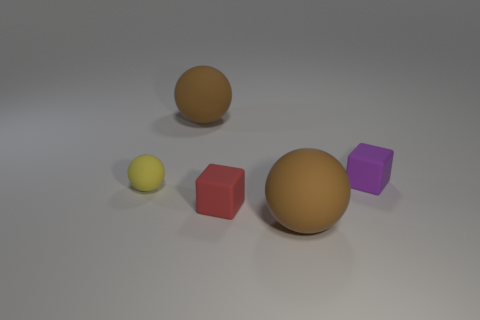Add 1 purple cubes. How many objects exist? 6 Subtract all balls. How many objects are left? 2 Add 2 small purple blocks. How many small purple blocks are left? 3 Add 1 matte cubes. How many matte cubes exist? 3 Subtract 1 brown balls. How many objects are left? 4 Subtract all red cubes. Subtract all tiny red things. How many objects are left? 3 